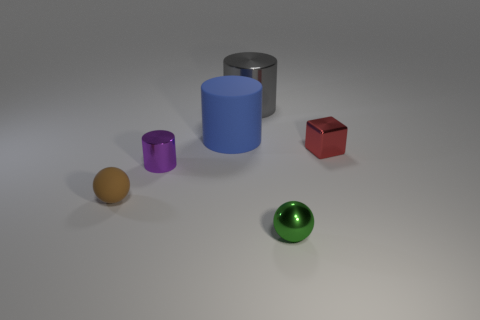Does the green object have the same shape as the brown object?
Your answer should be very brief. Yes. What is the color of the tiny block that is made of the same material as the gray cylinder?
Keep it short and to the point. Red. How many objects are either tiny things behind the tiny green thing or tiny cylinders?
Offer a very short reply. 3. How big is the shiny sphere in front of the small red metallic object?
Offer a terse response. Small. There is a green shiny object; does it have the same size as the sphere that is on the left side of the purple object?
Offer a terse response. Yes. What is the color of the big object right of the large object that is to the left of the large metal cylinder?
Provide a succinct answer. Gray. What number of other objects are the same color as the metal ball?
Your response must be concise. 0. What size is the gray shiny cylinder?
Make the answer very short. Large. Are there more tiny green metal spheres that are in front of the cube than green balls to the left of the blue rubber cylinder?
Your answer should be very brief. Yes. What number of blue rubber cylinders are to the left of the ball that is left of the large metallic object?
Provide a short and direct response. 0. 